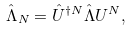Convert formula to latex. <formula><loc_0><loc_0><loc_500><loc_500>\hat { \Lambda } _ { N } = \hat { U } ^ { \dagger N } \hat { \Lambda } U ^ { N } ,</formula> 